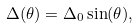<formula> <loc_0><loc_0><loc_500><loc_500>\Delta ( \theta ) = \Delta _ { 0 } \sin ( \theta ) ,</formula> 